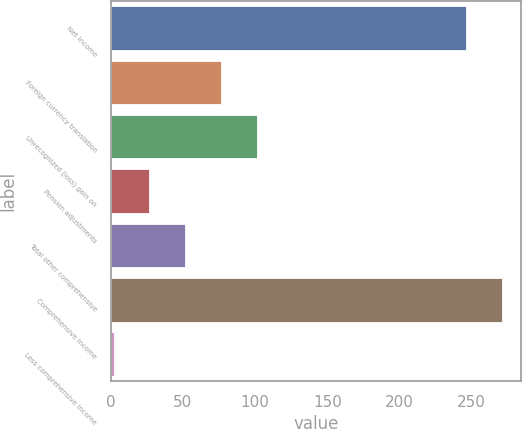Convert chart. <chart><loc_0><loc_0><loc_500><loc_500><bar_chart><fcel>Net income<fcel>Foreign currency translation<fcel>Unrecognized (loss) gain on<fcel>Pension adjustments<fcel>Total other comprehensive<fcel>Comprehensive income<fcel>Less comprehensive income<nl><fcel>246<fcel>76.4<fcel>101.2<fcel>26.8<fcel>51.6<fcel>270.8<fcel>2<nl></chart> 